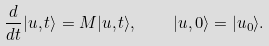<formula> <loc_0><loc_0><loc_500><loc_500>\frac { d } { d t } | u , t \rangle = M | u , t \rangle , \quad | u , 0 \rangle = | u _ { 0 } \rangle .</formula> 